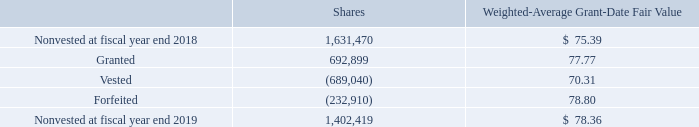Restricted Share Awards
Restricted share awards, which are generally in the form of restricted share units, are granted subject to certain restrictions. Conditions of vesting are determined at the time of grant. All restrictions on an award will lapse upon death or disability of the employee. If the employee satisfies retirement requirements, a portion of the award may vest, depending on the terms and conditions of the particular grant. Recipients of restricted share units have no voting rights, but do receive dividend equivalents. For grants that vest through passage of time, the fair value of the award at the time of the grant is amortized to expense over the period of vesting. The fair value of restricted share awards is determined based on the closing value of our shares on the grant date. Restricted share awards generally vest in increments over a period of four years as determined by the management development and compensation committee.
Restricted share award activity was as follows:
The weighted-average grant-date fair value of restricted share awards granted during fiscal 2019, 2018, and 2017 was $77.77, $93.45, and $67.72, respectively.
The total fair value of restricted share awards that vested during fiscal 2019, 2018, and 2017 was $48 million, $50 million, and $50 million, respectively.
As of fiscal year end 2019, there was $64 million of unrecognized compensation expense related to nonvested restricted share awards, which is expected to be recognized over a weighted-average period of 1.7 years.
What was the weighted-average grant-date fair value of restricted share awards granted during fiscal 2019? $77.77. What was the total fair value of restricted share awards that vested during fiscal 2019? $48 million. What were the components of restricted share award activity under Nonvested at fiscal year end 2018 in the table? Granted, vested, forfeited. In which year was the weighted-average grant-date fair value of restricted share awards granted the largest? $93.45>$77.77>$67.72
Answer: 2018. What was the change in the Weighted-Average Grant-Date Fair Value for nonvested shares in 2019 from 2018? $78.36-$75.39
Answer: 2.97. What was the percentage change in the Weighted-Average Grant-Date Fair Value for nonvested shares in 2019 from 2018?
Answer scale should be: percent. ($78.36-$75.39)/$75.39
Answer: 3.94. 